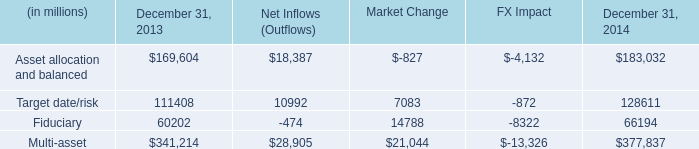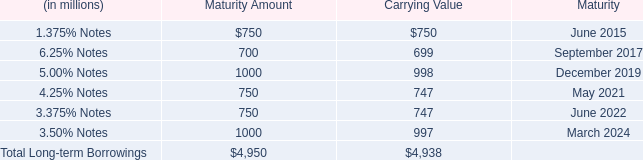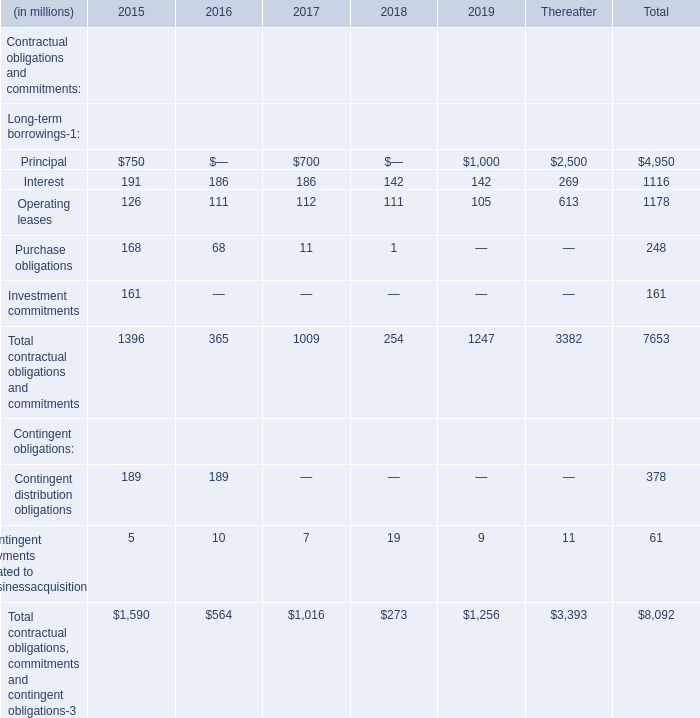What's the sum of Contingent obligations in 2015? (in million) 
Computations: (189 + 5)
Answer: 194.0. 